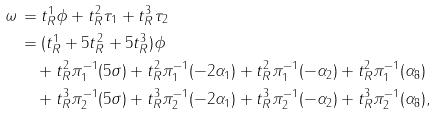Convert formula to latex. <formula><loc_0><loc_0><loc_500><loc_500>\omega \, & = t ^ { 1 } _ { R } \phi + t ^ { 2 } _ { R } \tau _ { 1 } + t ^ { 3 } _ { R } \tau _ { 2 } \\ & = ( t ^ { 1 } _ { R } + 5 t ^ { 2 } _ { R } + 5 t ^ { 3 } _ { R } ) \phi \\ & \quad + t ^ { 2 } _ { R } \pi _ { 1 } ^ { - 1 } ( 5 \sigma ) + t ^ { 2 } _ { R } \pi _ { 1 } ^ { - 1 } ( - 2 \alpha _ { 1 } ) + t ^ { 2 } _ { R } \pi _ { 1 } ^ { - 1 } ( - \alpha _ { 2 } ) + t ^ { 2 } _ { R } \pi _ { 1 } ^ { - 1 } ( \alpha _ { 8 } ) \\ & \quad + t ^ { 3 } _ { R } \pi _ { 2 } ^ { - 1 } ( 5 \sigma ) + t ^ { 3 } _ { R } \pi _ { 2 } ^ { - 1 } ( - 2 \alpha _ { 1 } ) + t ^ { 3 } _ { R } \pi _ { 2 } ^ { - 1 } ( - \alpha _ { 2 } ) + t ^ { 3 } _ { R } \pi _ { 2 } ^ { - 1 } ( \alpha _ { 8 } ) ,</formula> 